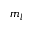Convert formula to latex. <formula><loc_0><loc_0><loc_500><loc_500>m _ { l }</formula> 